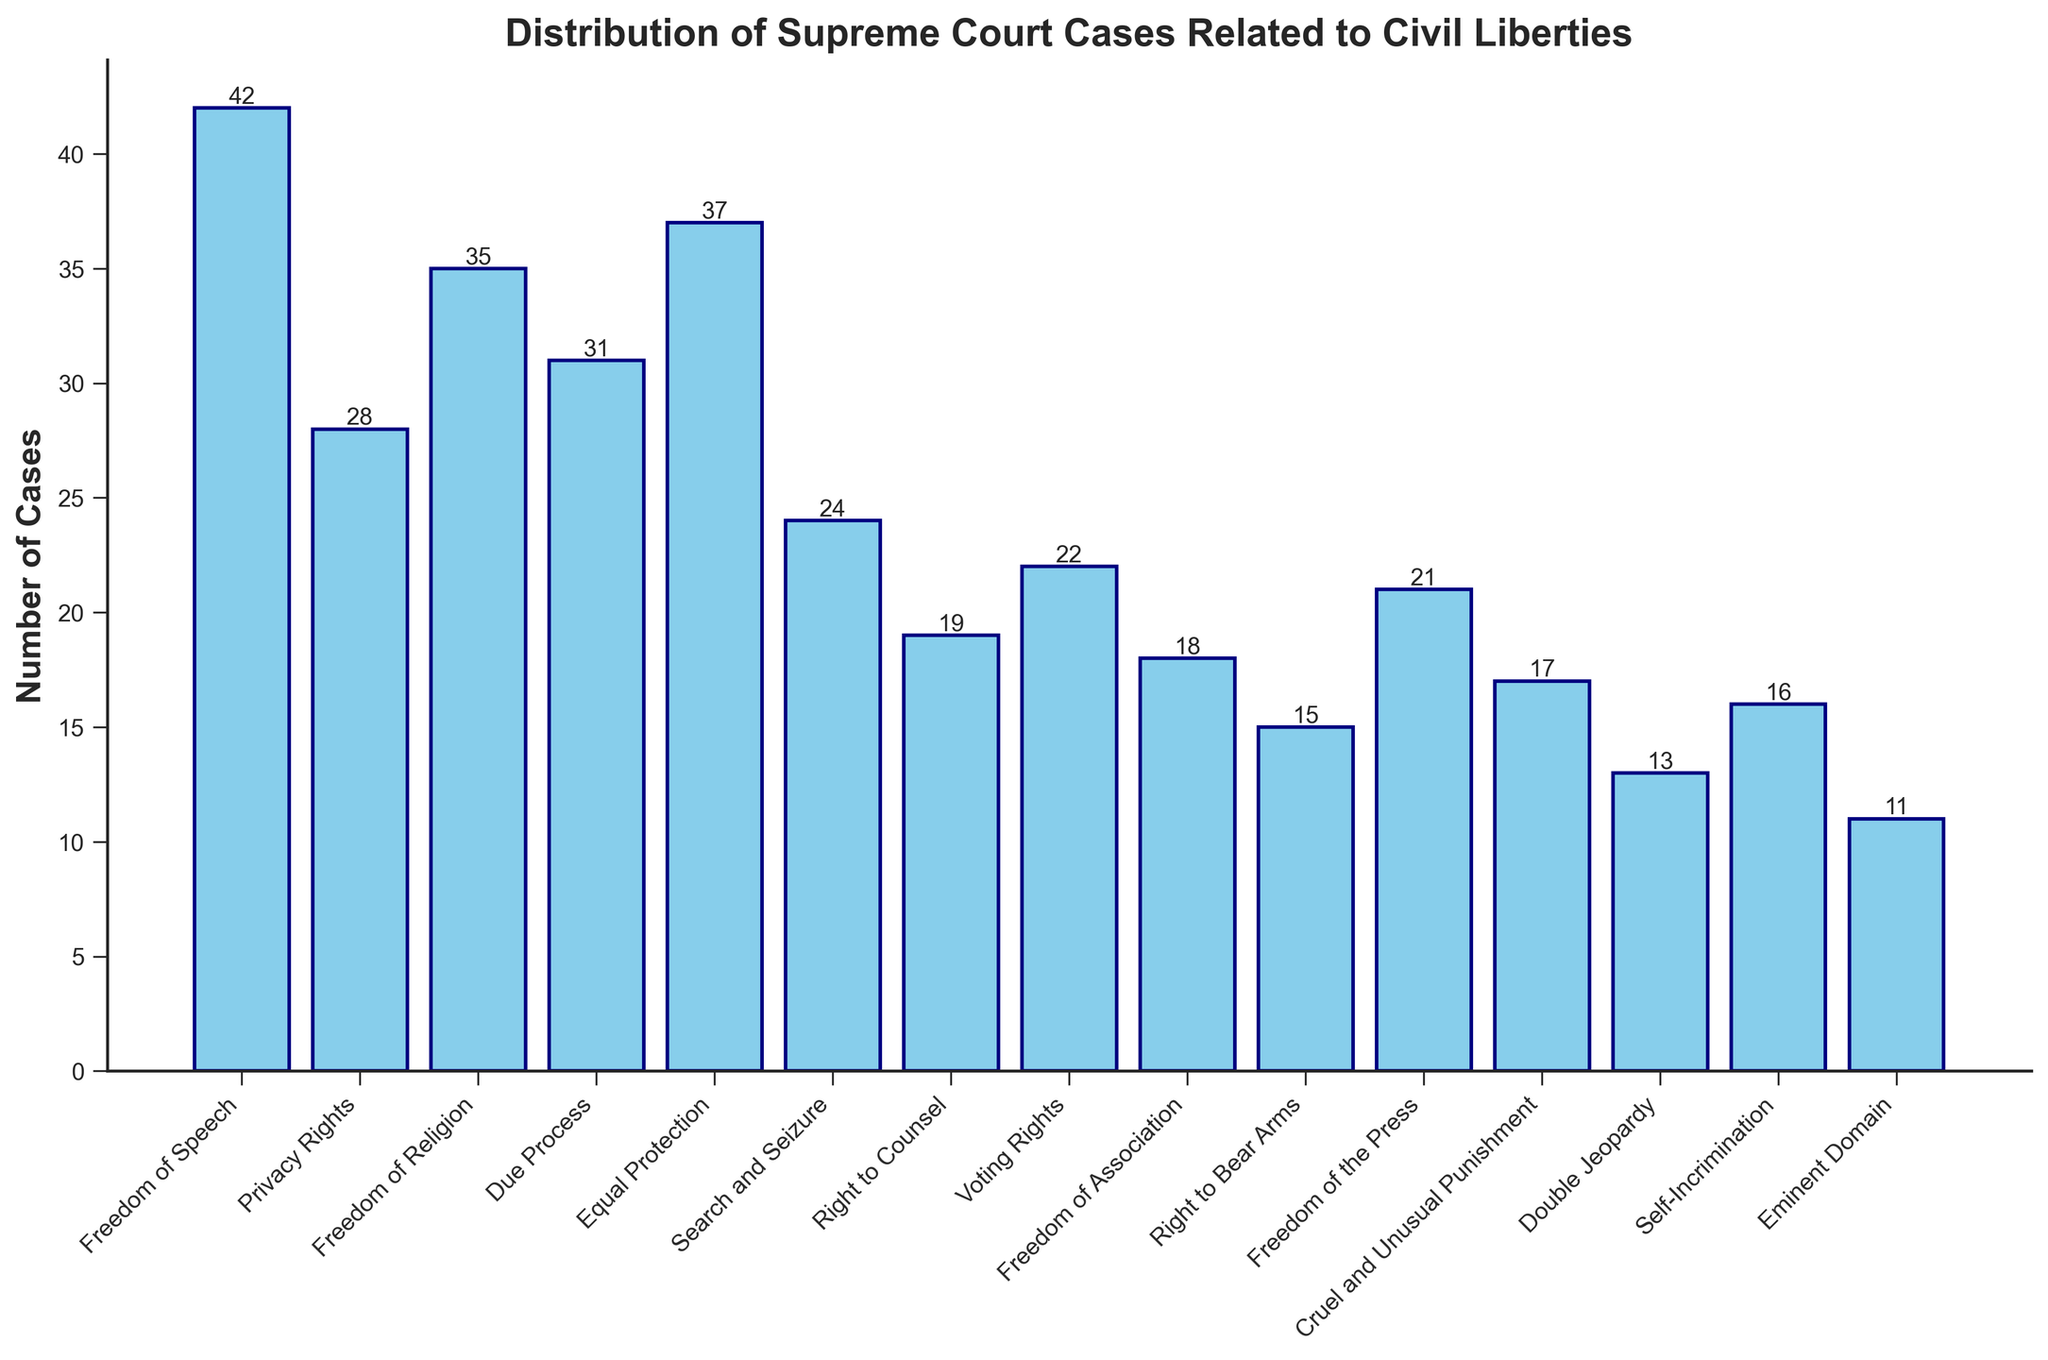Which category has the highest number of Supreme Court cases? By observing the height of the bars, the "Freedom of Speech" category has the tallest bar compared to all other categories.
Answer: Freedom of Speech Which category has the fewest Supreme Court cases? By checking the shortest bar in the figure, "Eminent Domain" has the shortest bar among all categories.
Answer: Eminent Domain What is the total number of Supreme Court cases related to "Due Process" and "Equal Protection"? Add the number of cases for "Due Process" (31) and "Equal Protection" (37). 31 + 37 = 68.
Answer: 68 How many more cases are related to "Freedom of Religion" than "Search and Seizure"? Subtract the number of "Search and Seizure" cases (24) from "Freedom of Religion" cases (35). 35 - 24 = 11.
Answer: 11 What is the difference in the number of cases between the category with the highest and the category with the lowest number of cases? The highest is "Freedom of Speech" with 42 cases and the lowest is "Eminent Domain" with 11 cases. Subtract 11 from 42. 42 - 11 = 31.
Answer: 31 List the categories where the number of cases is greater than or equal to 30. Scan the figure for bars with heights equal to or greater than 30. These categories are "Freedom of Speech" (42), "Freedom of Religion" (35), "Equal Protection" (37), and "Due Process" (31).
Answer: Freedom of Speech, Freedom of Religion, Equal Protection, Due Process What is the average number of cases for "Privacy Rights," "Freedom of the Press," and "Voting Rights"? Add the number of cases for "Privacy Rights" (28), "Freedom of the Press" (21), and "Voting Rights" (22), then divide by 3. (28 + 21 + 22) / 3 = 71 / 3 ≈ 23.67.
Answer: 23.67 Is the number of cases for "Right to Bear Arms" less than for "Self-Incrimination"? Compare the number of cases: "Right to Bear Arms" has 15, and "Self-Incrimination" has 16. Yes, 15 is less than 16.
Answer: Yes What is the total number of cases in all categories combined? Sum the number of cases for all categories listed. 42 + 28 + 35 + 31 + 37 + 24 + 19 + 22 + 18 + 15 + 21 + 17 + 13 + 16 + 11 = 349.
Answer: 349 Which category has 19 cases? Identify the bar with a label showing a height of 19. The "Right to Counsel" category has 19 cases.
Answer: Right to Counsel 